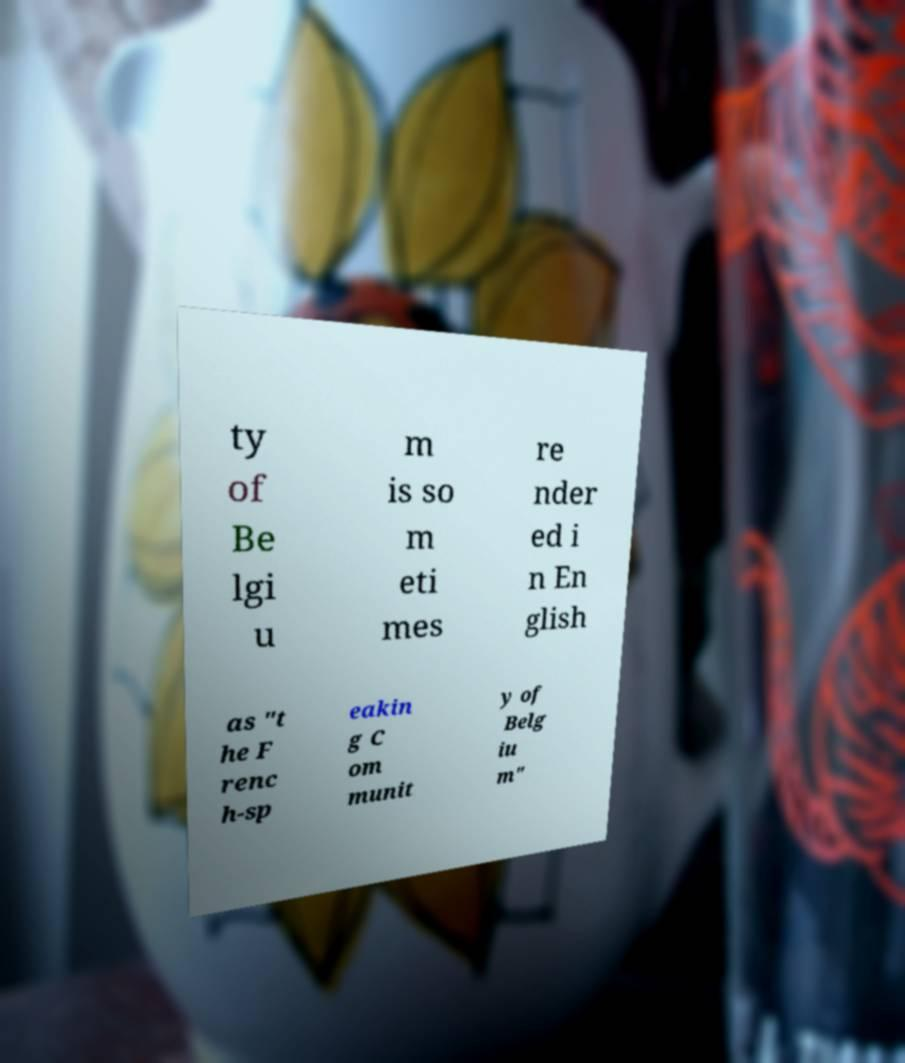Can you read and provide the text displayed in the image?This photo seems to have some interesting text. Can you extract and type it out for me? ty of Be lgi u m is so m eti mes re nder ed i n En glish as "t he F renc h-sp eakin g C om munit y of Belg iu m" 